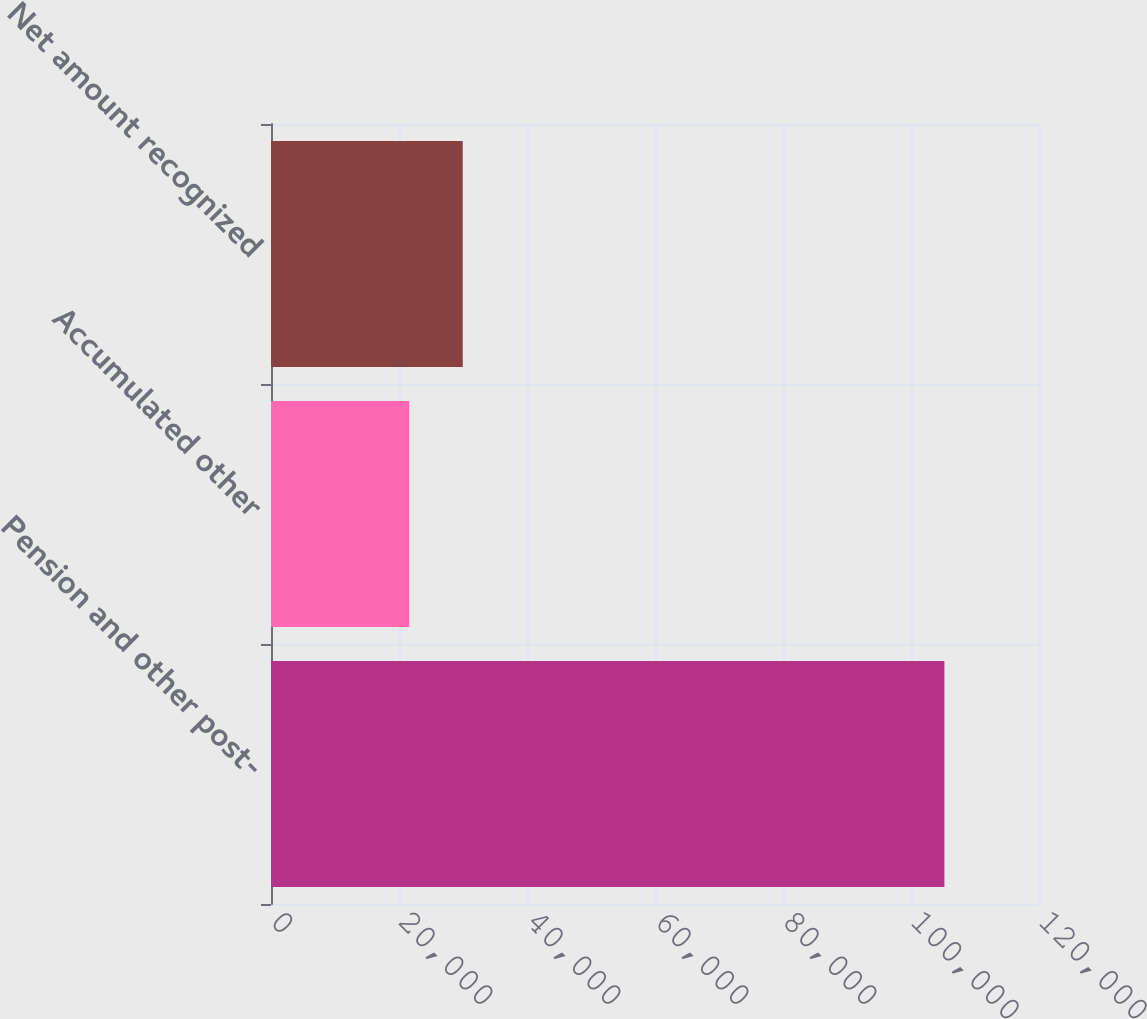<chart> <loc_0><loc_0><loc_500><loc_500><bar_chart><fcel>Pension and other post-<fcel>Accumulated other<fcel>Net amount recognized<nl><fcel>105217<fcel>21593<fcel>29955.4<nl></chart> 